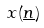<formula> <loc_0><loc_0><loc_500><loc_500>x ( \underline { n } )</formula> 